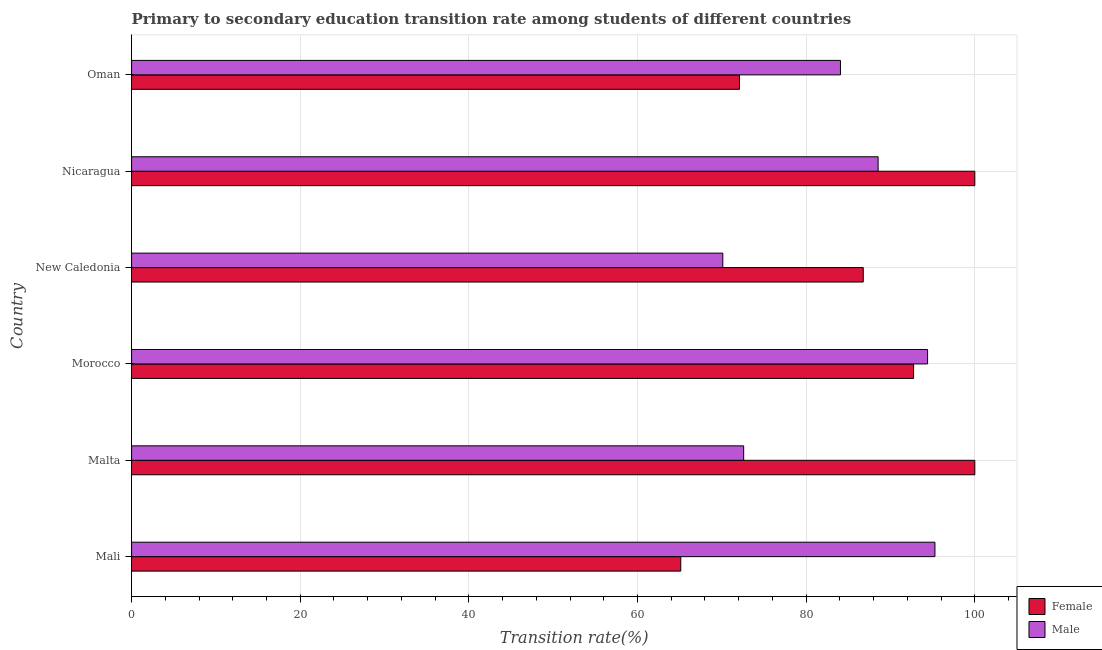How many groups of bars are there?
Your answer should be compact. 6. How many bars are there on the 2nd tick from the top?
Provide a short and direct response. 2. How many bars are there on the 6th tick from the bottom?
Make the answer very short. 2. What is the label of the 2nd group of bars from the top?
Give a very brief answer. Nicaragua. In how many cases, is the number of bars for a given country not equal to the number of legend labels?
Make the answer very short. 0. What is the transition rate among female students in New Caledonia?
Provide a succinct answer. 86.77. Across all countries, what is the maximum transition rate among female students?
Ensure brevity in your answer.  100. Across all countries, what is the minimum transition rate among male students?
Give a very brief answer. 70.12. In which country was the transition rate among female students maximum?
Your response must be concise. Malta. In which country was the transition rate among female students minimum?
Your answer should be compact. Mali. What is the total transition rate among female students in the graph?
Make the answer very short. 516.73. What is the difference between the transition rate among female students in Morocco and that in Nicaragua?
Keep it short and to the point. -7.26. What is the difference between the transition rate among female students in Mali and the transition rate among male students in Malta?
Offer a very short reply. -7.46. What is the average transition rate among male students per country?
Make the answer very short. 84.16. What is the difference between the transition rate among male students and transition rate among female students in Nicaragua?
Your response must be concise. -11.47. In how many countries, is the transition rate among female students greater than 72 %?
Your answer should be compact. 5. What is the ratio of the transition rate among female students in New Caledonia to that in Nicaragua?
Keep it short and to the point. 0.87. Is the transition rate among female students in Mali less than that in New Caledonia?
Offer a terse response. Yes. Is the difference between the transition rate among female students in Mali and Malta greater than the difference between the transition rate among male students in Mali and Malta?
Provide a short and direct response. No. What is the difference between the highest and the second highest transition rate among male students?
Your answer should be very brief. 0.87. What is the difference between the highest and the lowest transition rate among male students?
Provide a short and direct response. 25.16. Is the sum of the transition rate among female students in Malta and New Caledonia greater than the maximum transition rate among male students across all countries?
Give a very brief answer. Yes. What does the 2nd bar from the top in Oman represents?
Ensure brevity in your answer.  Female. What does the 2nd bar from the bottom in Nicaragua represents?
Make the answer very short. Male. How many bars are there?
Ensure brevity in your answer.  12. Are all the bars in the graph horizontal?
Offer a terse response. Yes. How many countries are there in the graph?
Your answer should be very brief. 6. Does the graph contain grids?
Make the answer very short. Yes. Where does the legend appear in the graph?
Provide a short and direct response. Bottom right. How many legend labels are there?
Ensure brevity in your answer.  2. How are the legend labels stacked?
Offer a terse response. Vertical. What is the title of the graph?
Give a very brief answer. Primary to secondary education transition rate among students of different countries. What is the label or title of the X-axis?
Your response must be concise. Transition rate(%). What is the Transition rate(%) in Female in Mali?
Your response must be concise. 65.13. What is the Transition rate(%) of Male in Mali?
Ensure brevity in your answer.  95.27. What is the Transition rate(%) in Female in Malta?
Ensure brevity in your answer.  100. What is the Transition rate(%) of Male in Malta?
Make the answer very short. 72.59. What is the Transition rate(%) in Female in Morocco?
Your response must be concise. 92.74. What is the Transition rate(%) in Male in Morocco?
Keep it short and to the point. 94.4. What is the Transition rate(%) of Female in New Caledonia?
Your response must be concise. 86.77. What is the Transition rate(%) in Male in New Caledonia?
Offer a very short reply. 70.12. What is the Transition rate(%) in Female in Nicaragua?
Provide a short and direct response. 100. What is the Transition rate(%) of Male in Nicaragua?
Offer a terse response. 88.53. What is the Transition rate(%) of Female in Oman?
Offer a terse response. 72.09. What is the Transition rate(%) of Male in Oman?
Offer a very short reply. 84.07. Across all countries, what is the maximum Transition rate(%) in Male?
Offer a very short reply. 95.27. Across all countries, what is the minimum Transition rate(%) of Female?
Your answer should be compact. 65.13. Across all countries, what is the minimum Transition rate(%) in Male?
Offer a terse response. 70.12. What is the total Transition rate(%) of Female in the graph?
Your answer should be very brief. 516.73. What is the total Transition rate(%) of Male in the graph?
Offer a very short reply. 504.97. What is the difference between the Transition rate(%) in Female in Mali and that in Malta?
Provide a succinct answer. -34.87. What is the difference between the Transition rate(%) in Male in Mali and that in Malta?
Provide a short and direct response. 22.68. What is the difference between the Transition rate(%) of Female in Mali and that in Morocco?
Give a very brief answer. -27.61. What is the difference between the Transition rate(%) in Male in Mali and that in Morocco?
Provide a short and direct response. 0.87. What is the difference between the Transition rate(%) in Female in Mali and that in New Caledonia?
Your answer should be compact. -21.64. What is the difference between the Transition rate(%) in Male in Mali and that in New Caledonia?
Provide a succinct answer. 25.16. What is the difference between the Transition rate(%) in Female in Mali and that in Nicaragua?
Give a very brief answer. -34.87. What is the difference between the Transition rate(%) in Male in Mali and that in Nicaragua?
Offer a terse response. 6.74. What is the difference between the Transition rate(%) of Female in Mali and that in Oman?
Provide a succinct answer. -6.96. What is the difference between the Transition rate(%) of Male in Mali and that in Oman?
Your response must be concise. 11.2. What is the difference between the Transition rate(%) in Female in Malta and that in Morocco?
Provide a short and direct response. 7.26. What is the difference between the Transition rate(%) in Male in Malta and that in Morocco?
Your response must be concise. -21.81. What is the difference between the Transition rate(%) of Female in Malta and that in New Caledonia?
Give a very brief answer. 13.23. What is the difference between the Transition rate(%) in Male in Malta and that in New Caledonia?
Give a very brief answer. 2.47. What is the difference between the Transition rate(%) in Female in Malta and that in Nicaragua?
Keep it short and to the point. 0. What is the difference between the Transition rate(%) in Male in Malta and that in Nicaragua?
Offer a terse response. -15.94. What is the difference between the Transition rate(%) of Female in Malta and that in Oman?
Your answer should be compact. 27.91. What is the difference between the Transition rate(%) in Male in Malta and that in Oman?
Your answer should be very brief. -11.48. What is the difference between the Transition rate(%) in Female in Morocco and that in New Caledonia?
Your answer should be compact. 5.97. What is the difference between the Transition rate(%) in Male in Morocco and that in New Caledonia?
Provide a short and direct response. 24.28. What is the difference between the Transition rate(%) of Female in Morocco and that in Nicaragua?
Provide a succinct answer. -7.26. What is the difference between the Transition rate(%) in Male in Morocco and that in Nicaragua?
Give a very brief answer. 5.87. What is the difference between the Transition rate(%) in Female in Morocco and that in Oman?
Ensure brevity in your answer.  20.65. What is the difference between the Transition rate(%) of Male in Morocco and that in Oman?
Give a very brief answer. 10.33. What is the difference between the Transition rate(%) of Female in New Caledonia and that in Nicaragua?
Keep it short and to the point. -13.23. What is the difference between the Transition rate(%) of Male in New Caledonia and that in Nicaragua?
Your answer should be very brief. -18.42. What is the difference between the Transition rate(%) of Female in New Caledonia and that in Oman?
Offer a terse response. 14.68. What is the difference between the Transition rate(%) of Male in New Caledonia and that in Oman?
Provide a succinct answer. -13.95. What is the difference between the Transition rate(%) of Female in Nicaragua and that in Oman?
Your answer should be compact. 27.91. What is the difference between the Transition rate(%) in Male in Nicaragua and that in Oman?
Make the answer very short. 4.46. What is the difference between the Transition rate(%) of Female in Mali and the Transition rate(%) of Male in Malta?
Keep it short and to the point. -7.46. What is the difference between the Transition rate(%) in Female in Mali and the Transition rate(%) in Male in Morocco?
Your answer should be very brief. -29.27. What is the difference between the Transition rate(%) in Female in Mali and the Transition rate(%) in Male in New Caledonia?
Provide a succinct answer. -4.99. What is the difference between the Transition rate(%) of Female in Mali and the Transition rate(%) of Male in Nicaragua?
Keep it short and to the point. -23.4. What is the difference between the Transition rate(%) of Female in Mali and the Transition rate(%) of Male in Oman?
Offer a terse response. -18.94. What is the difference between the Transition rate(%) in Female in Malta and the Transition rate(%) in Male in Morocco?
Ensure brevity in your answer.  5.6. What is the difference between the Transition rate(%) of Female in Malta and the Transition rate(%) of Male in New Caledonia?
Your answer should be very brief. 29.88. What is the difference between the Transition rate(%) of Female in Malta and the Transition rate(%) of Male in Nicaragua?
Make the answer very short. 11.47. What is the difference between the Transition rate(%) in Female in Malta and the Transition rate(%) in Male in Oman?
Provide a short and direct response. 15.93. What is the difference between the Transition rate(%) in Female in Morocco and the Transition rate(%) in Male in New Caledonia?
Offer a terse response. 22.62. What is the difference between the Transition rate(%) of Female in Morocco and the Transition rate(%) of Male in Nicaragua?
Your response must be concise. 4.21. What is the difference between the Transition rate(%) in Female in Morocco and the Transition rate(%) in Male in Oman?
Give a very brief answer. 8.67. What is the difference between the Transition rate(%) in Female in New Caledonia and the Transition rate(%) in Male in Nicaragua?
Make the answer very short. -1.76. What is the difference between the Transition rate(%) of Female in New Caledonia and the Transition rate(%) of Male in Oman?
Give a very brief answer. 2.7. What is the difference between the Transition rate(%) of Female in Nicaragua and the Transition rate(%) of Male in Oman?
Keep it short and to the point. 15.93. What is the average Transition rate(%) of Female per country?
Your answer should be compact. 86.12. What is the average Transition rate(%) in Male per country?
Your answer should be very brief. 84.16. What is the difference between the Transition rate(%) in Female and Transition rate(%) in Male in Mali?
Keep it short and to the point. -30.14. What is the difference between the Transition rate(%) in Female and Transition rate(%) in Male in Malta?
Give a very brief answer. 27.41. What is the difference between the Transition rate(%) of Female and Transition rate(%) of Male in Morocco?
Make the answer very short. -1.66. What is the difference between the Transition rate(%) of Female and Transition rate(%) of Male in New Caledonia?
Provide a short and direct response. 16.65. What is the difference between the Transition rate(%) of Female and Transition rate(%) of Male in Nicaragua?
Make the answer very short. 11.47. What is the difference between the Transition rate(%) of Female and Transition rate(%) of Male in Oman?
Your response must be concise. -11.98. What is the ratio of the Transition rate(%) in Female in Mali to that in Malta?
Make the answer very short. 0.65. What is the ratio of the Transition rate(%) in Male in Mali to that in Malta?
Make the answer very short. 1.31. What is the ratio of the Transition rate(%) in Female in Mali to that in Morocco?
Offer a terse response. 0.7. What is the ratio of the Transition rate(%) of Male in Mali to that in Morocco?
Give a very brief answer. 1.01. What is the ratio of the Transition rate(%) in Female in Mali to that in New Caledonia?
Provide a succinct answer. 0.75. What is the ratio of the Transition rate(%) in Male in Mali to that in New Caledonia?
Offer a terse response. 1.36. What is the ratio of the Transition rate(%) of Female in Mali to that in Nicaragua?
Give a very brief answer. 0.65. What is the ratio of the Transition rate(%) in Male in Mali to that in Nicaragua?
Offer a very short reply. 1.08. What is the ratio of the Transition rate(%) in Female in Mali to that in Oman?
Your response must be concise. 0.9. What is the ratio of the Transition rate(%) in Male in Mali to that in Oman?
Your answer should be very brief. 1.13. What is the ratio of the Transition rate(%) of Female in Malta to that in Morocco?
Provide a succinct answer. 1.08. What is the ratio of the Transition rate(%) in Male in Malta to that in Morocco?
Provide a succinct answer. 0.77. What is the ratio of the Transition rate(%) of Female in Malta to that in New Caledonia?
Offer a very short reply. 1.15. What is the ratio of the Transition rate(%) of Male in Malta to that in New Caledonia?
Offer a very short reply. 1.04. What is the ratio of the Transition rate(%) of Female in Malta to that in Nicaragua?
Provide a short and direct response. 1. What is the ratio of the Transition rate(%) of Male in Malta to that in Nicaragua?
Provide a succinct answer. 0.82. What is the ratio of the Transition rate(%) in Female in Malta to that in Oman?
Give a very brief answer. 1.39. What is the ratio of the Transition rate(%) of Male in Malta to that in Oman?
Your answer should be very brief. 0.86. What is the ratio of the Transition rate(%) in Female in Morocco to that in New Caledonia?
Provide a succinct answer. 1.07. What is the ratio of the Transition rate(%) in Male in Morocco to that in New Caledonia?
Your response must be concise. 1.35. What is the ratio of the Transition rate(%) of Female in Morocco to that in Nicaragua?
Provide a succinct answer. 0.93. What is the ratio of the Transition rate(%) of Male in Morocco to that in Nicaragua?
Your answer should be compact. 1.07. What is the ratio of the Transition rate(%) in Female in Morocco to that in Oman?
Provide a short and direct response. 1.29. What is the ratio of the Transition rate(%) of Male in Morocco to that in Oman?
Ensure brevity in your answer.  1.12. What is the ratio of the Transition rate(%) of Female in New Caledonia to that in Nicaragua?
Give a very brief answer. 0.87. What is the ratio of the Transition rate(%) in Male in New Caledonia to that in Nicaragua?
Ensure brevity in your answer.  0.79. What is the ratio of the Transition rate(%) in Female in New Caledonia to that in Oman?
Make the answer very short. 1.2. What is the ratio of the Transition rate(%) of Male in New Caledonia to that in Oman?
Give a very brief answer. 0.83. What is the ratio of the Transition rate(%) of Female in Nicaragua to that in Oman?
Your response must be concise. 1.39. What is the ratio of the Transition rate(%) in Male in Nicaragua to that in Oman?
Your answer should be compact. 1.05. What is the difference between the highest and the second highest Transition rate(%) of Female?
Your answer should be compact. 0. What is the difference between the highest and the second highest Transition rate(%) in Male?
Your response must be concise. 0.87. What is the difference between the highest and the lowest Transition rate(%) of Female?
Provide a succinct answer. 34.87. What is the difference between the highest and the lowest Transition rate(%) in Male?
Offer a terse response. 25.16. 